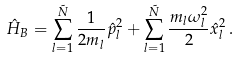<formula> <loc_0><loc_0><loc_500><loc_500>\hat { H } _ { B } = \sum _ { l = 1 } ^ { \tilde { N } } \frac { 1 } { 2 m _ { l } } \hat { p } ^ { 2 } _ { l } + \sum _ { l = 1 } ^ { \tilde { N } } \frac { m _ { l } \omega _ { l } ^ { 2 } } { 2 } \hat { x } ^ { 2 } _ { l } \, .</formula> 